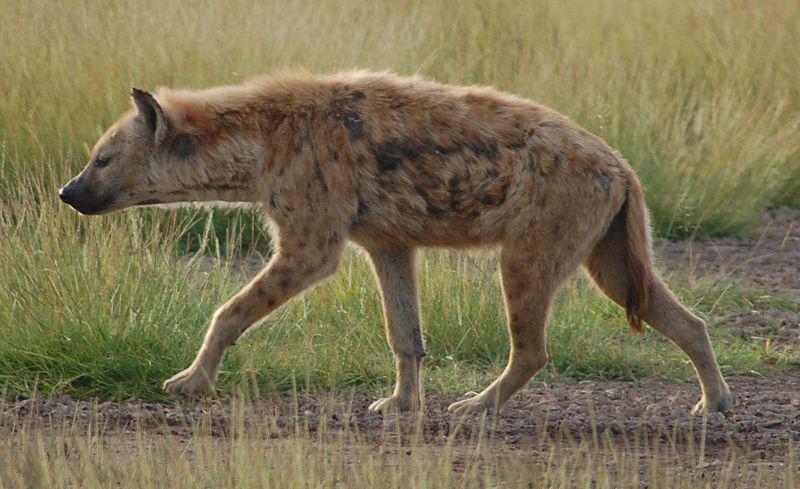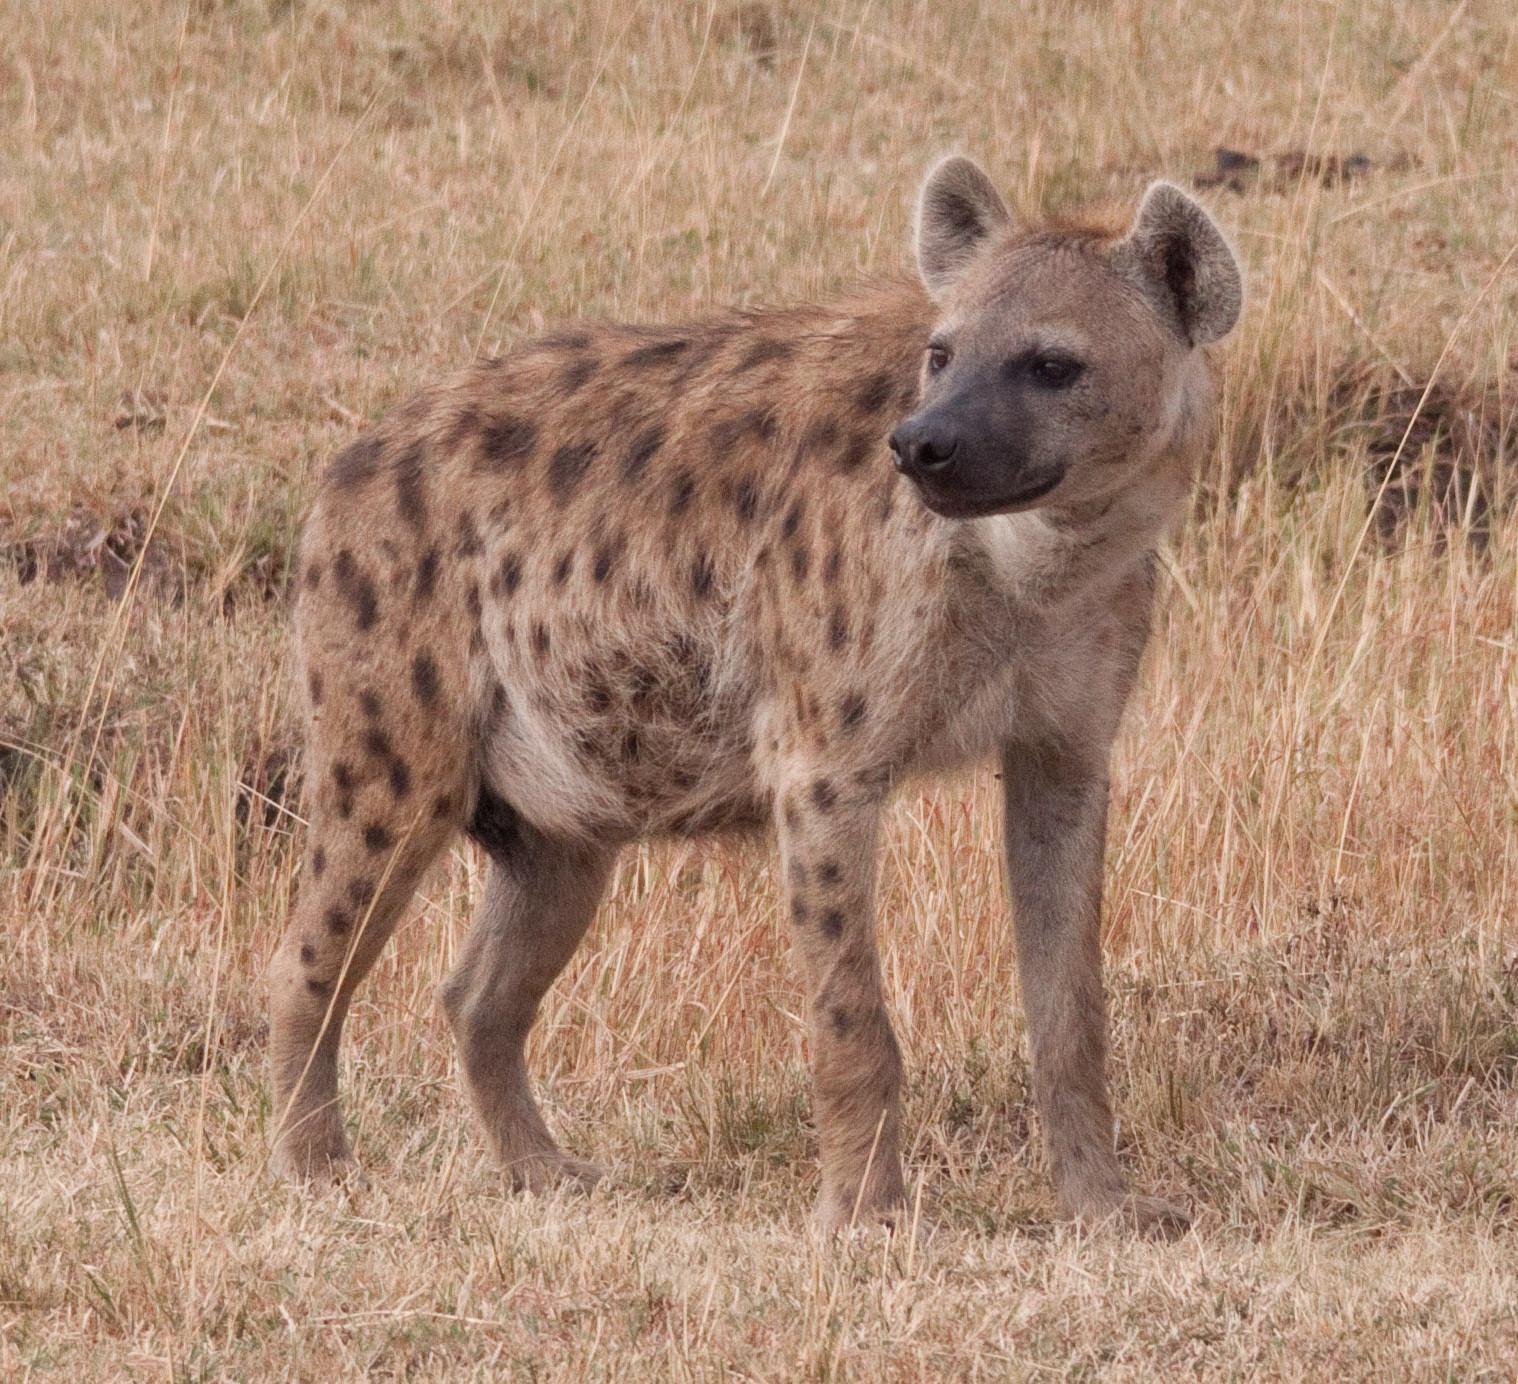The first image is the image on the left, the second image is the image on the right. Considering the images on both sides, is "The hyena in the image on the left has something in its mouth." valid? Answer yes or no. No. The first image is the image on the left, the second image is the image on the right. Assess this claim about the two images: "The right image contains exactly two hyenas.". Correct or not? Answer yes or no. No. 